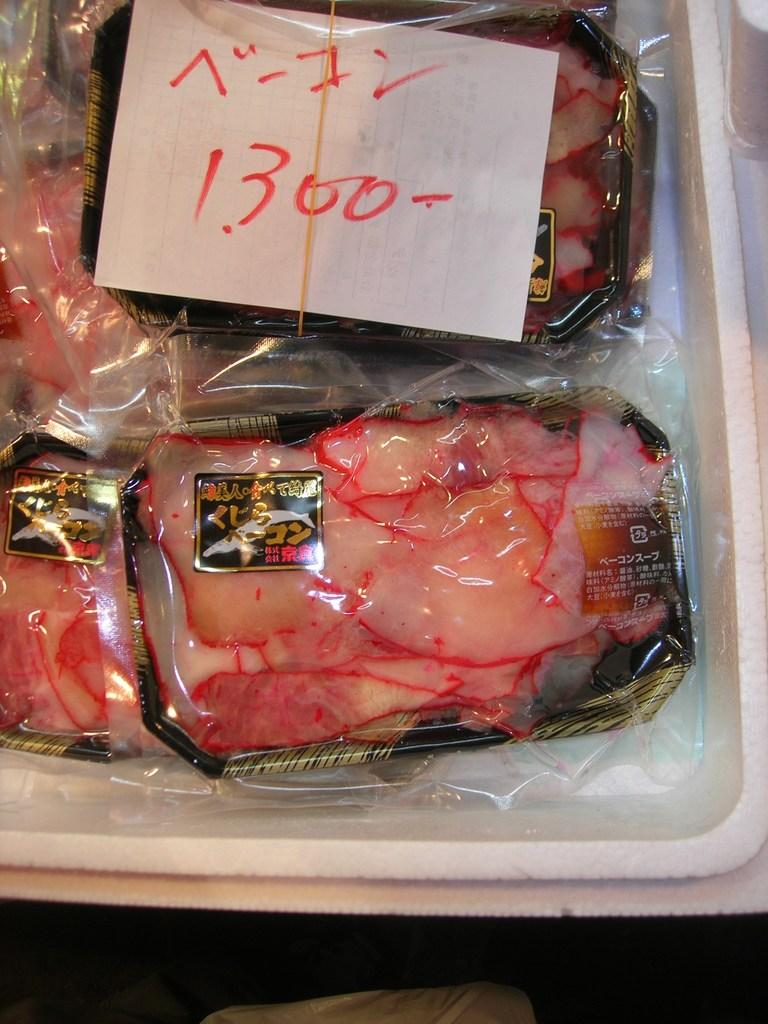What type of containers are visible in the image? There are food boxes in the image. How are the food boxes protected in the image? The food boxes are covered with plastic covers. What is the color of the box on which the food boxes are placed? The food boxes are on a white color box. What type of paper can be seen in the image? There is a white paper in the image. Can you hear the queen ringing the bells in the image? There is no queen or bells present in the image, so it is not possible to hear them ringing. 